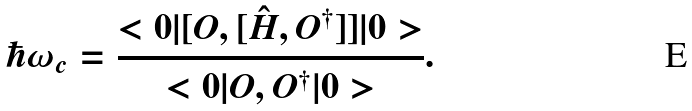<formula> <loc_0><loc_0><loc_500><loc_500>\hbar { \omega } _ { c } = \frac { < 0 | [ O , [ \hat { H } , O ^ { \dag } ] ] | 0 > } { < 0 | O , O ^ { \dag } | 0 > } .</formula> 